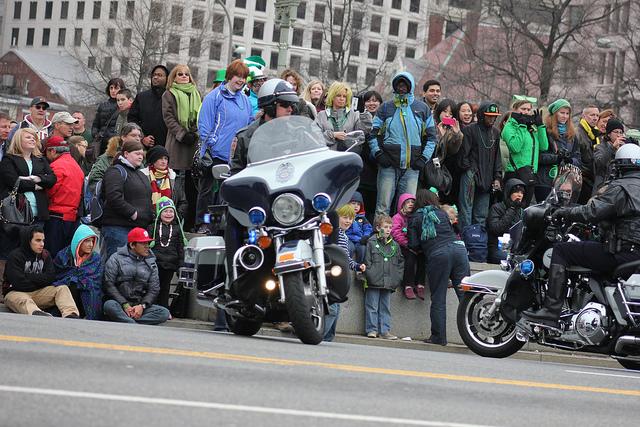Does the first bike have a windshield?
Concise answer only. Yes. Are the policemen on motorcycles?
Keep it brief. Yes. Which emergency department can use blue lights on their vehicles?
Quick response, please. Police. Why are people gathered beside the street?
Write a very short answer. Parade. 